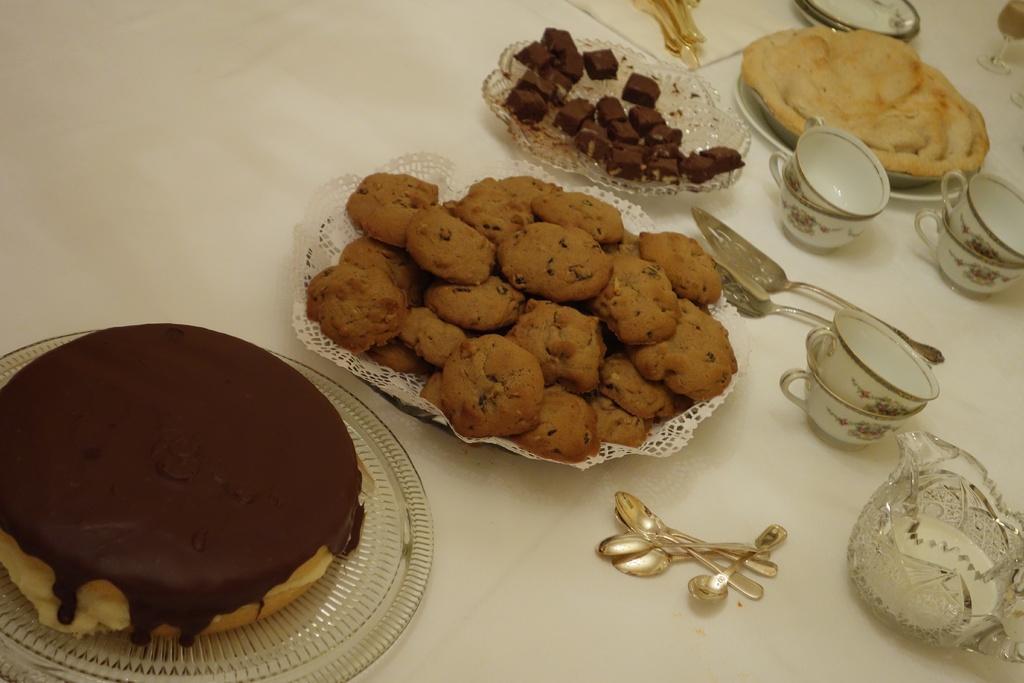In one or two sentences, can you explain what this image depicts? In the foreground of this image, there are cookies, cake, chocolates and a food item on platters. We can also see spoons, spatulas, cups, jar, glasses, platters on the table. 